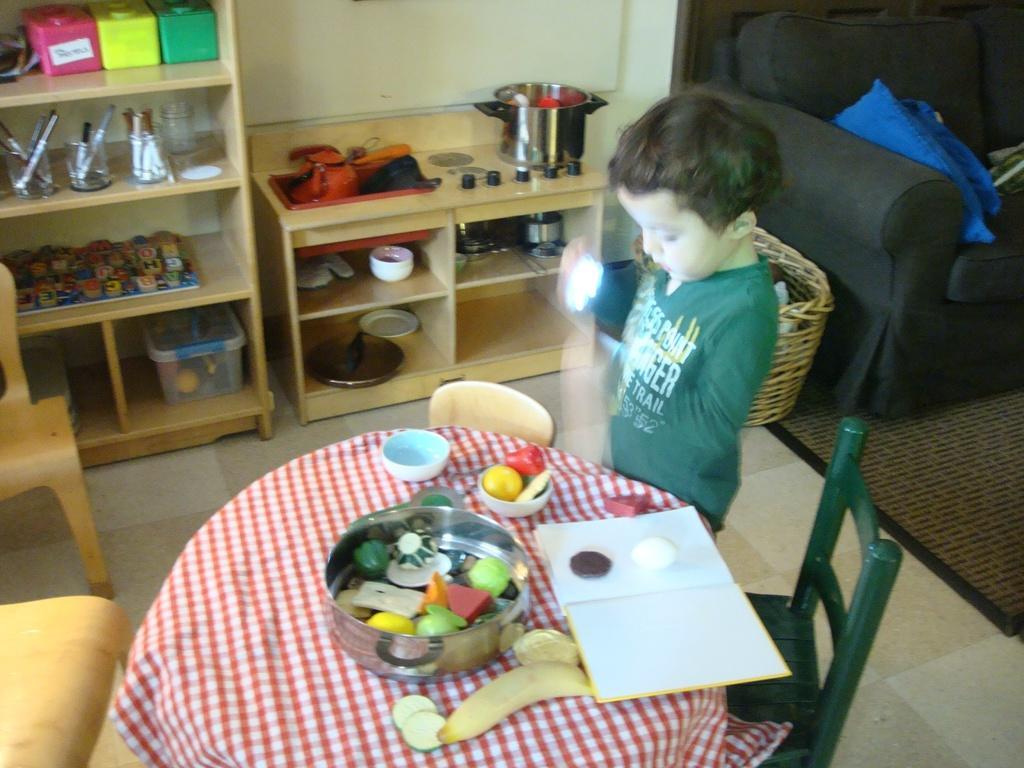Describe this image in one or two sentences. In the picture we can see a house inside it, we can see a round table with some chairs and a child standing near the table on the table, we can see a bowl with some toys and beside it, we can see a book which is opened and in the background, we can see wooden racks with some things in it and besides, we can see a sofa which is black in color with two pillows on it which are blue in color and to the floor we can see a floor mat. 